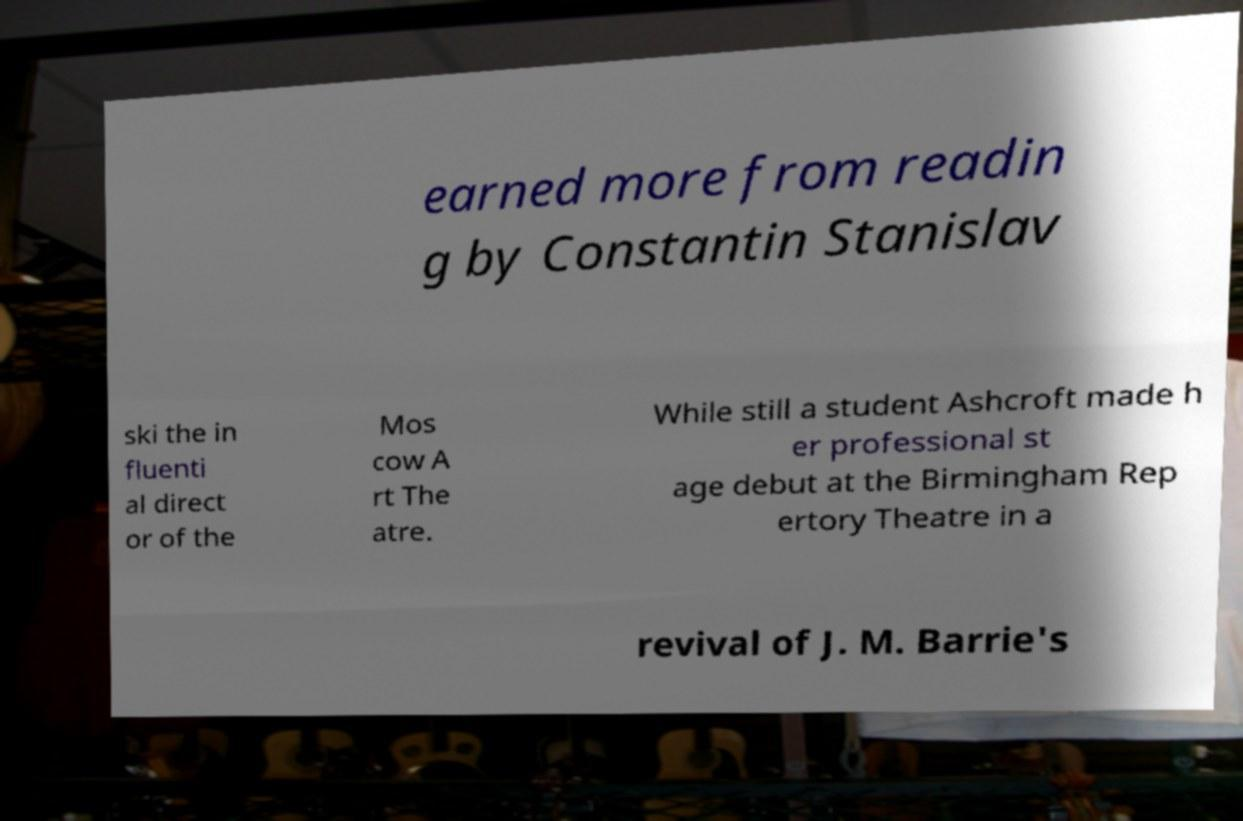Could you extract and type out the text from this image? earned more from readin g by Constantin Stanislav ski the in fluenti al direct or of the Mos cow A rt The atre. While still a student Ashcroft made h er professional st age debut at the Birmingham Rep ertory Theatre in a revival of J. M. Barrie's 